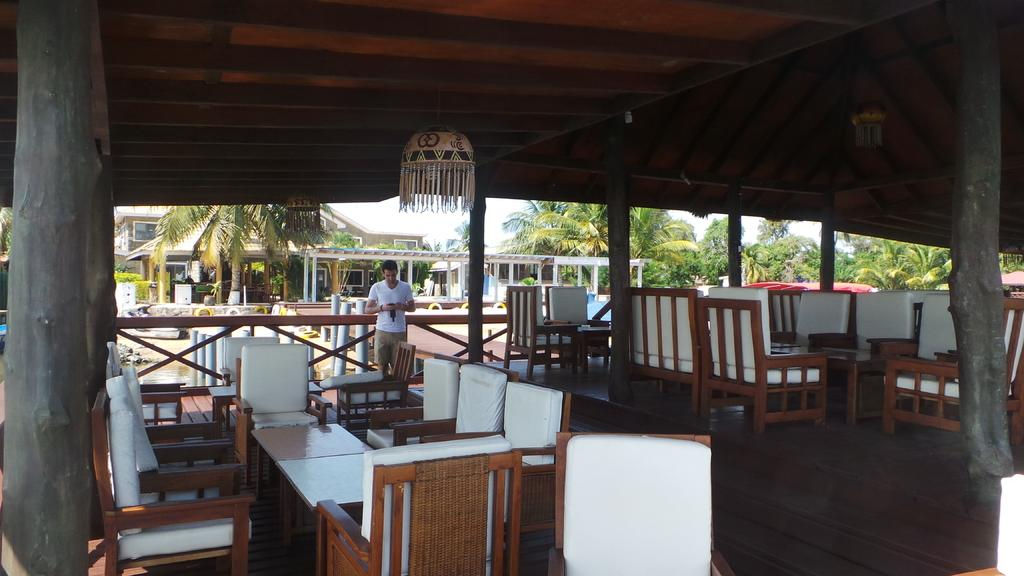What type of furniture is present in the image? There are chairs and tables in the image. What is the man in the image doing? The man is standing and holding a camera in his hand. What type of structure is visible in the image? There is a building in the image. What type of vegetation is present in the image? There are trees in the image. What type of decoration is present on the roof in the image? There are decorative hangings on the roof. Reasoning: Let'g: Let's think step by step in order to produce the conversation. We start by identifying the main subjects and objects in the image based on the provided facts. We then formulate questions that focus on the location and characteristics of these subjects and objects, ensuring that each question can be answered definitively with the information given. We avoid yes/no questions and ensure that the language is simple and clear. Absurd Question/Answer: What type of thunder can be heard in the image? There is no thunder present in the image, as it is a visual medium and does not contain sound. How many cushions are on the chairs in the image? The provided facts do not mention cushions on the chairs, so we cannot determine their presence or quantity. What type of income can be seen in the image? There is no income present in the image, as it is a visual medium and does not contain financial information. How many decorative hangings are on the trees in the image? The provided facts do not mention decorative hangings on the trees, so we cannot determine their presence or quantity. 